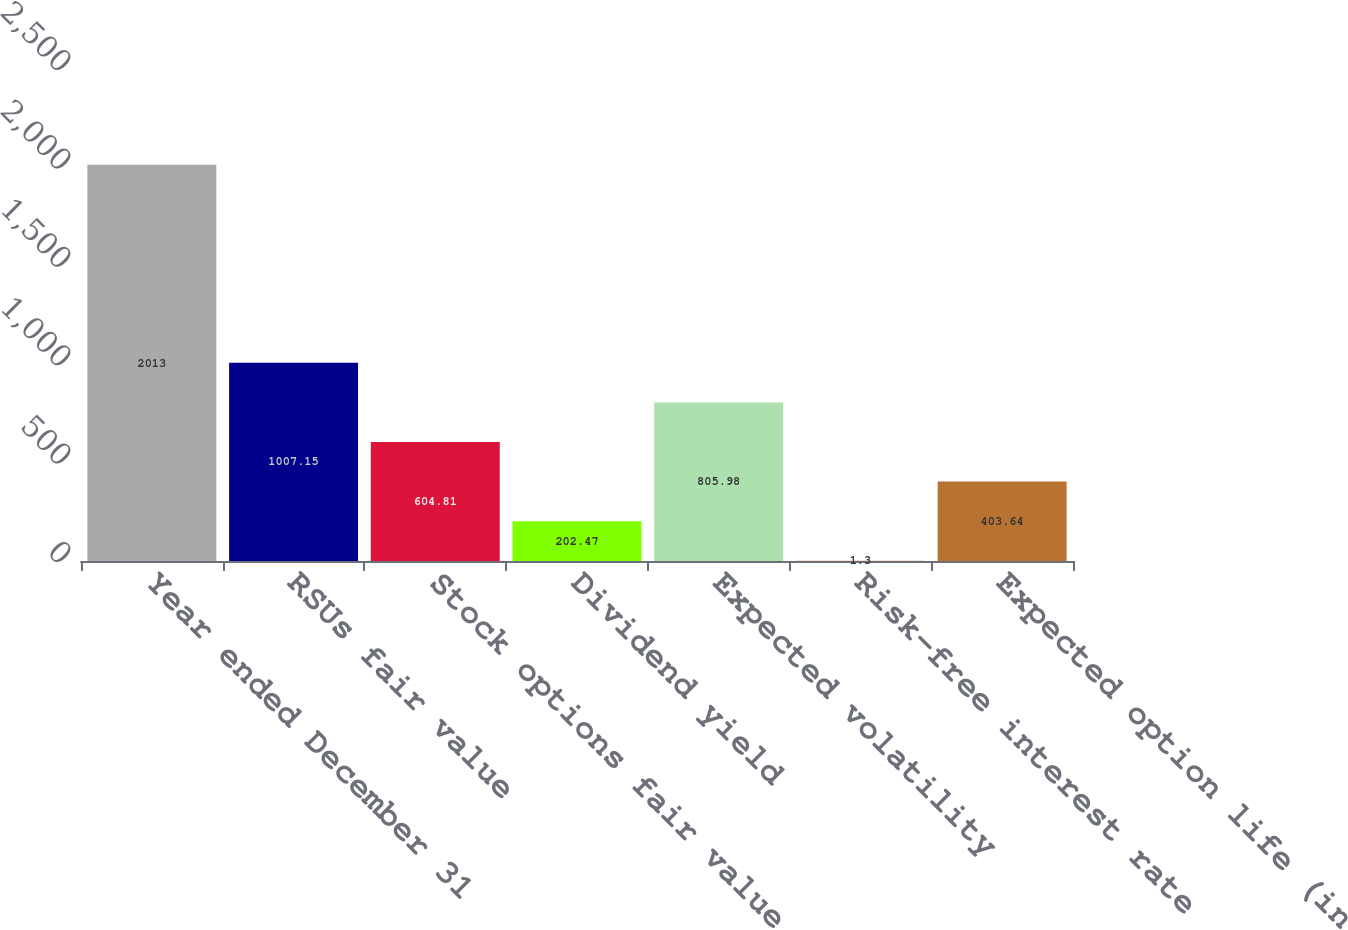Convert chart. <chart><loc_0><loc_0><loc_500><loc_500><bar_chart><fcel>Year ended December 31<fcel>RSUs fair value<fcel>Stock options fair value<fcel>Dividend yield<fcel>Expected volatility<fcel>Risk-free interest rate<fcel>Expected option life (in<nl><fcel>2013<fcel>1007.15<fcel>604.81<fcel>202.47<fcel>805.98<fcel>1.3<fcel>403.64<nl></chart> 